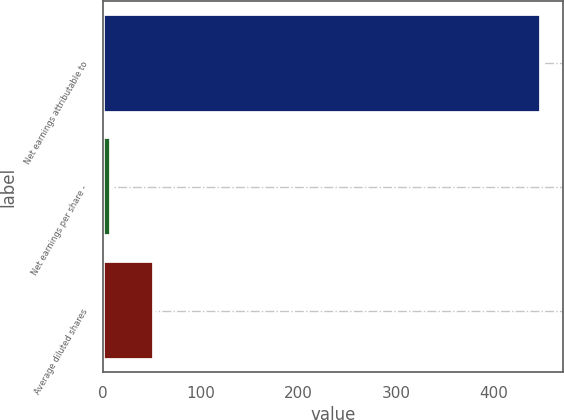<chart> <loc_0><loc_0><loc_500><loc_500><bar_chart><fcel>Net earnings attributable to<fcel>Net earnings per share -<fcel>Average diluted shares<nl><fcel>448.3<fcel>8.51<fcel>52.7<nl></chart> 